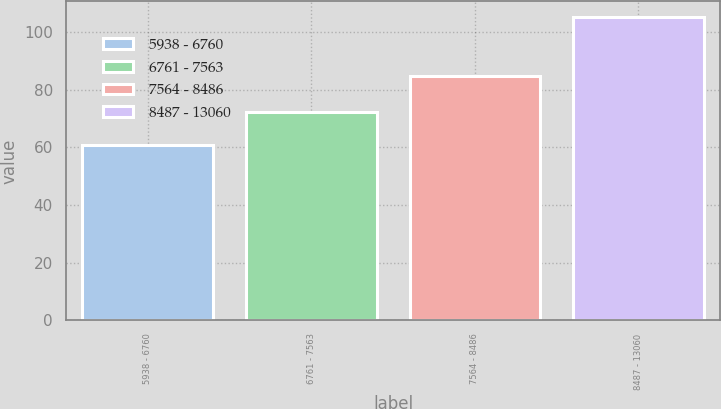Convert chart to OTSL. <chart><loc_0><loc_0><loc_500><loc_500><bar_chart><fcel>5938 - 6760<fcel>6761 - 7563<fcel>7564 - 8486<fcel>8487 - 13060<nl><fcel>60.64<fcel>72.06<fcel>84.73<fcel>105.29<nl></chart> 